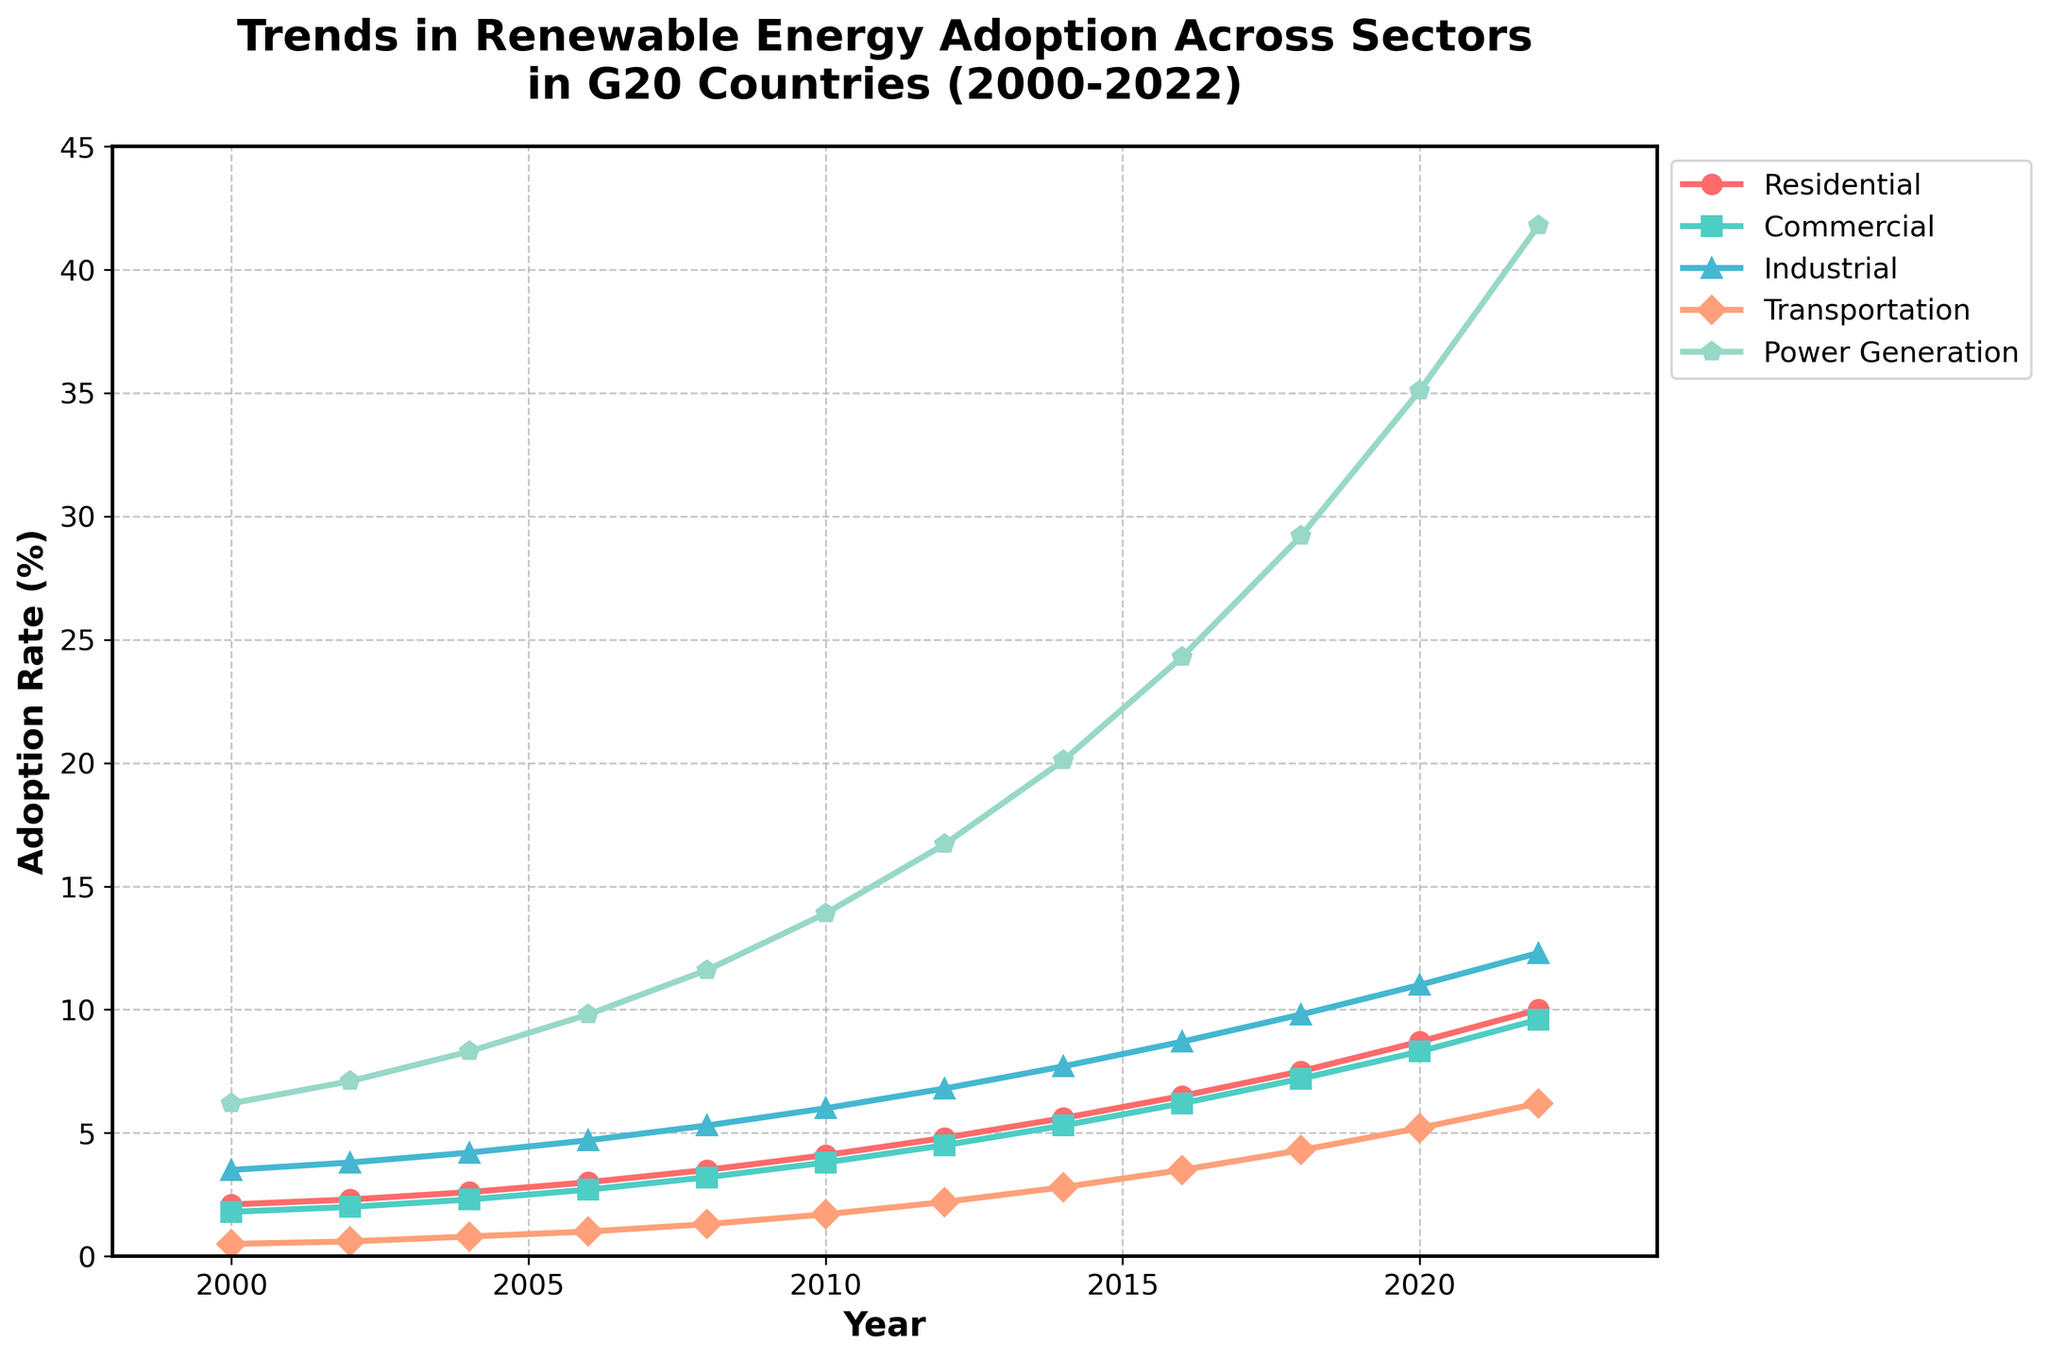What year saw the highest renewable energy adoption in the Residential sector? The line for the Residential sector is tracked, and the highest point is checked, which is at the year 2022 with 10.0%.
Answer: 2022 In 2010, which sector had the closest renewable energy adoption rate to 4%? By checking the points in 2010 along the y-axis, the closest sector to 4% is the Commercial sector at 3.8%.
Answer: Commercial What is the average adoption rate of renewable energy in the Industrial sector from 2000 to 2022? Calculate the sum of Industrial sector values and divide by the number of years (13): (3.5+3.8+4.2+4.7+5.3+6.0+6.8+7.7+8.7+9.8+11.0+12.3) / 12 = 86.8 / 12 ≈ 7.23
Answer: 7.23 Which sector had the largest increase in renewable energy adoption from 2006 to 2022? Subtract the adoption rates of 2006 from those of 2022 for each sector. The results are then compared. The Power Generation sector has the largest increase: 41.8 - 9.8 = 32.0.
Answer: Power Generation In which year did the Transportation sector surpass 2% adoption rate for the first time? The line for the Transportation sector is analyzed, and the first year it crossed 2% is in 2012.
Answer: 2012 Compare the increase in adoption rates between the Residential and Commercial sectors from 2000 to 2022. Subtract the 2000 values from the 2022 values for both sectors. Residential: 10.0 - 2.1 = 7.9 Commercial: 9.6 - 1.8 = 7.8. The Residential sector had a slightly greater increase.
Answer: Residential What is the total renewable energy adoption in the year 2020 across all sectors? Add the values for all sectors in 2020: 8.7+8.3+11.0+5.2+35.1 ≈ 68.3.
Answer: 68.3 Between 2004 and 2020, which sector showed the steepest growth in renewable energy adoption? Calculate the difference between the 2004 and 2020 adoption rates and analyze these differences. Power Generation: 35.1-8.3=26.8, which is the steepest growth.
Answer: Power Generation By how much did the adoption rate in the Commercial sector increase from 2010 to 2014? Subtract the 2010 adoption rate from the 2014 rate in the Commercial sector: 5.3 - 3.8 = 1.5.
Answer: 1.5 Which sector had the smallest adoption rate in 2002, and what was it? Check the values for 2002; the sector with the smallest rate is Transportation at 0.6%.
Answer: Transportation, 0.6 